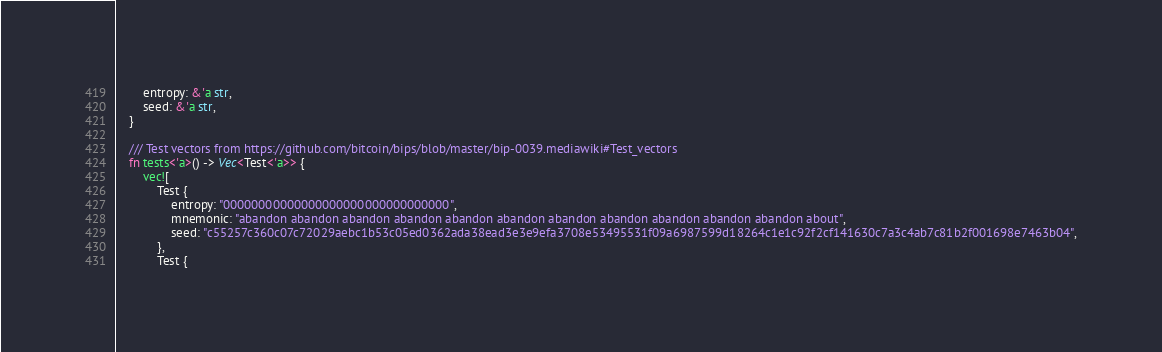<code> <loc_0><loc_0><loc_500><loc_500><_Rust_>		entropy: &'a str,
		seed: &'a str,
	}

	/// Test vectors from https://github.com/bitcoin/bips/blob/master/bip-0039.mediawiki#Test_vectors
	fn tests<'a>() -> Vec<Test<'a>> {
		vec![
            Test {
                entropy: "00000000000000000000000000000000",
                mnemonic: "abandon abandon abandon abandon abandon abandon abandon abandon abandon abandon abandon about",
                seed: "c55257c360c07c72029aebc1b53c05ed0362ada38ead3e3e9efa3708e53495531f09a6987599d18264c1e1c92f2cf141630c7a3c4ab7c81b2f001698e7463b04",
            },
            Test {</code> 